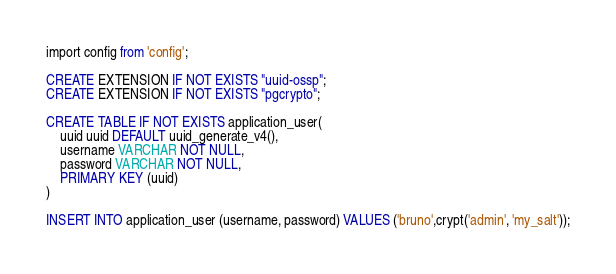Convert code to text. <code><loc_0><loc_0><loc_500><loc_500><_SQL_>import config from 'config';

CREATE EXTENSION IF NOT EXISTS "uuid-ossp";
CREATE EXTENSION IF NOT EXISTS "pgcrypto";

CREATE TABLE IF NOT EXISTS application_user(
    uuid uuid DEFAULT uuid_generate_v4(),
    username VARCHAR NOT NULL,
    password VARCHAR NOT NULL,
    PRIMARY KEY (uuid)
)

INSERT INTO application_user (username, password) VALUES ('bruno',crypt('admin', 'my_salt'));</code> 